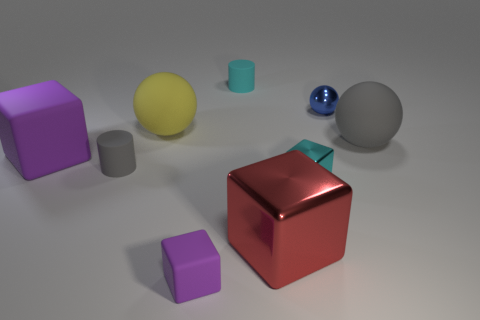Subtract all balls. How many objects are left? 6 Add 9 big green matte blocks. How many big green matte blocks exist? 9 Subtract 0 yellow cylinders. How many objects are left? 9 Subtract all yellow matte balls. Subtract all gray matte cylinders. How many objects are left? 7 Add 3 small gray objects. How many small gray objects are left? 4 